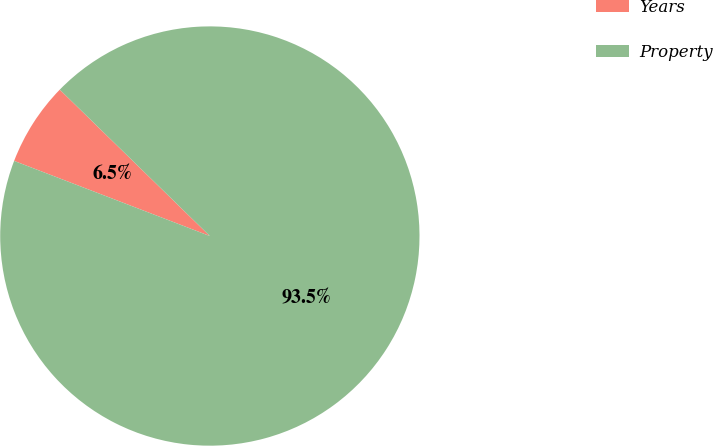Convert chart to OTSL. <chart><loc_0><loc_0><loc_500><loc_500><pie_chart><fcel>Years<fcel>Property<nl><fcel>6.47%<fcel>93.53%<nl></chart> 